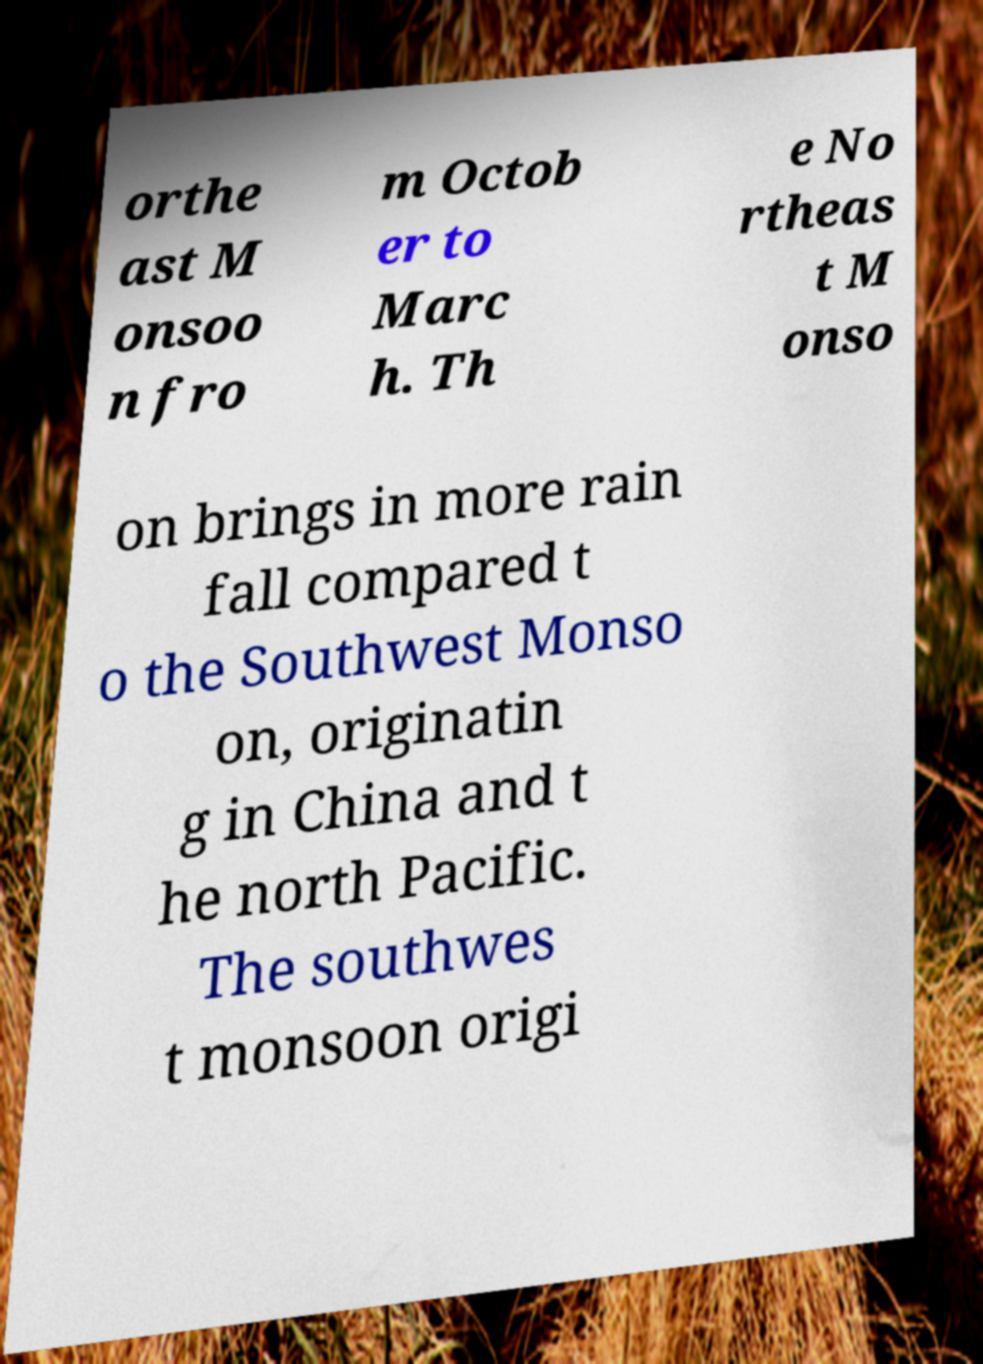Can you accurately transcribe the text from the provided image for me? orthe ast M onsoo n fro m Octob er to Marc h. Th e No rtheas t M onso on brings in more rain fall compared t o the Southwest Monso on, originatin g in China and t he north Pacific. The southwes t monsoon origi 